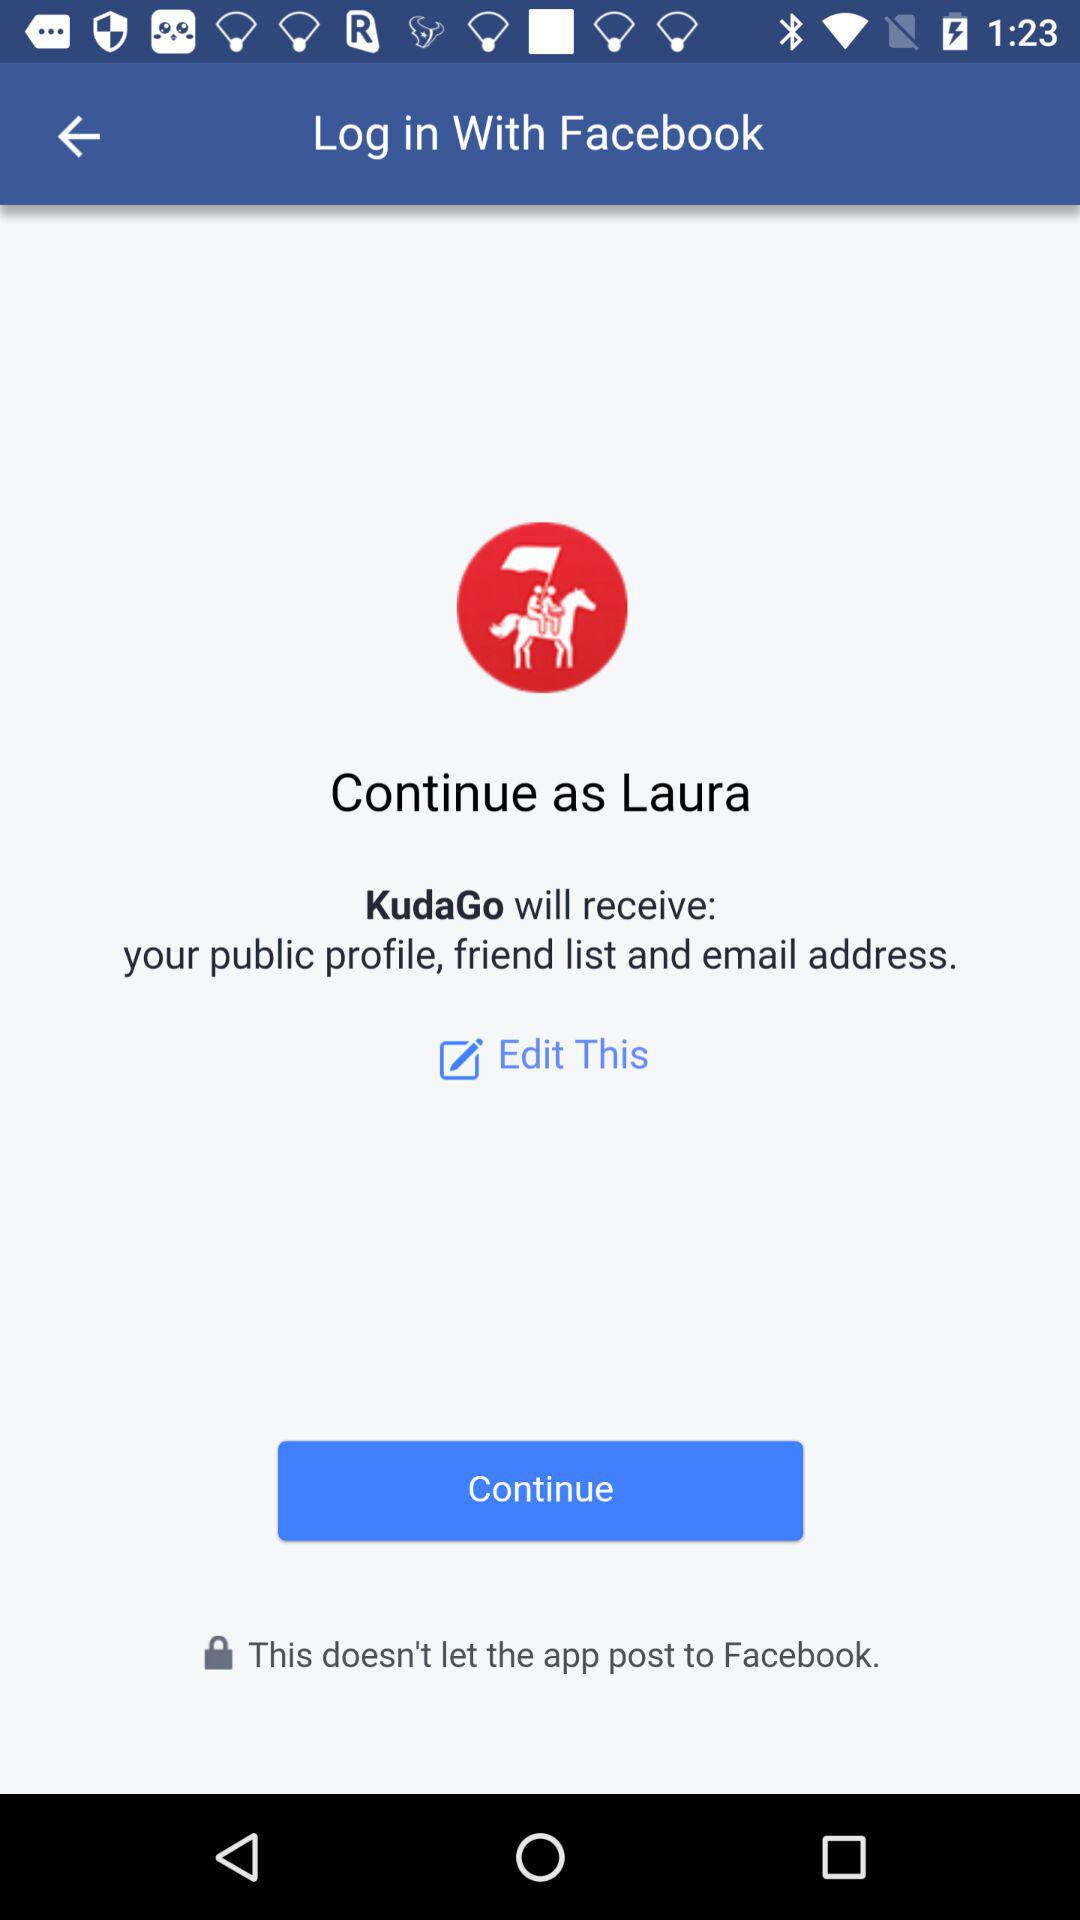What profile can be used to sign in? The profile that can be used to sign in is "Facebook". 